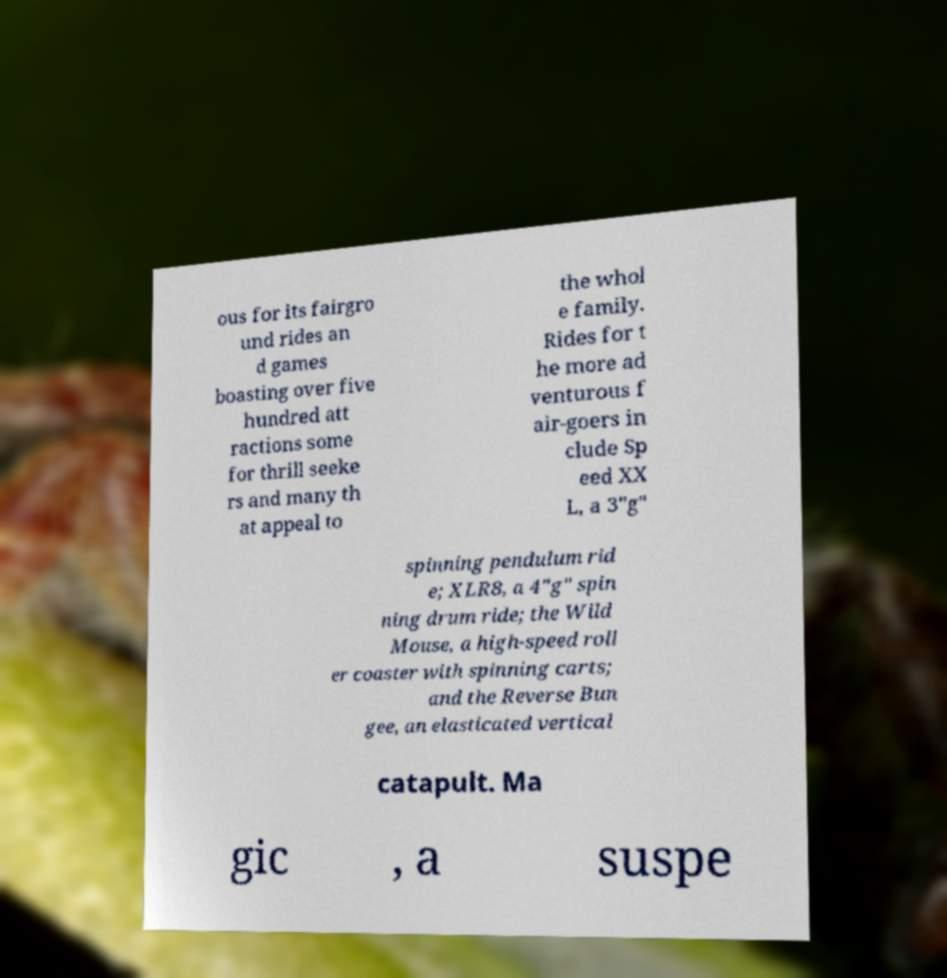Can you read and provide the text displayed in the image?This photo seems to have some interesting text. Can you extract and type it out for me? ous for its fairgro und rides an d games boasting over five hundred att ractions some for thrill seeke rs and many th at appeal to the whol e family. Rides for t he more ad venturous f air-goers in clude Sp eed XX L, a 3"g" spinning pendulum rid e; XLR8, a 4"g" spin ning drum ride; the Wild Mouse, a high-speed roll er coaster with spinning carts; and the Reverse Bun gee, an elasticated vertical catapult. Ma gic , a suspe 